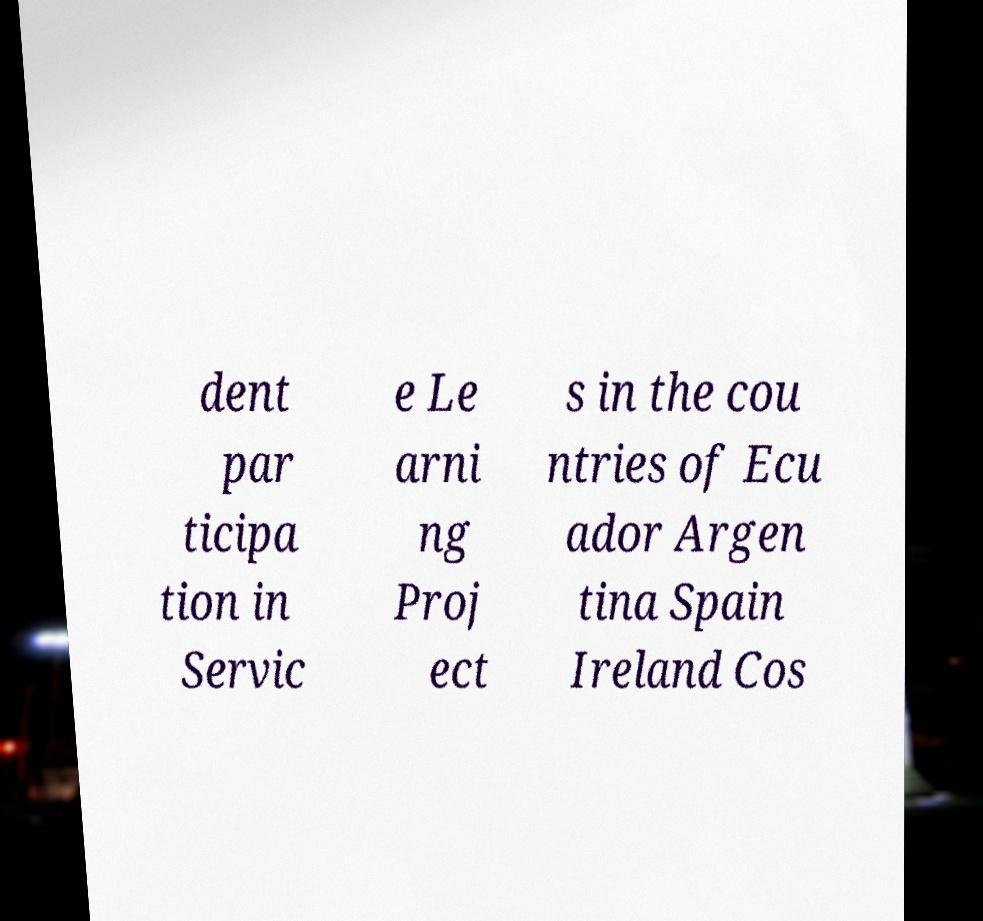I need the written content from this picture converted into text. Can you do that? dent par ticipa tion in Servic e Le arni ng Proj ect s in the cou ntries of Ecu ador Argen tina Spain Ireland Cos 